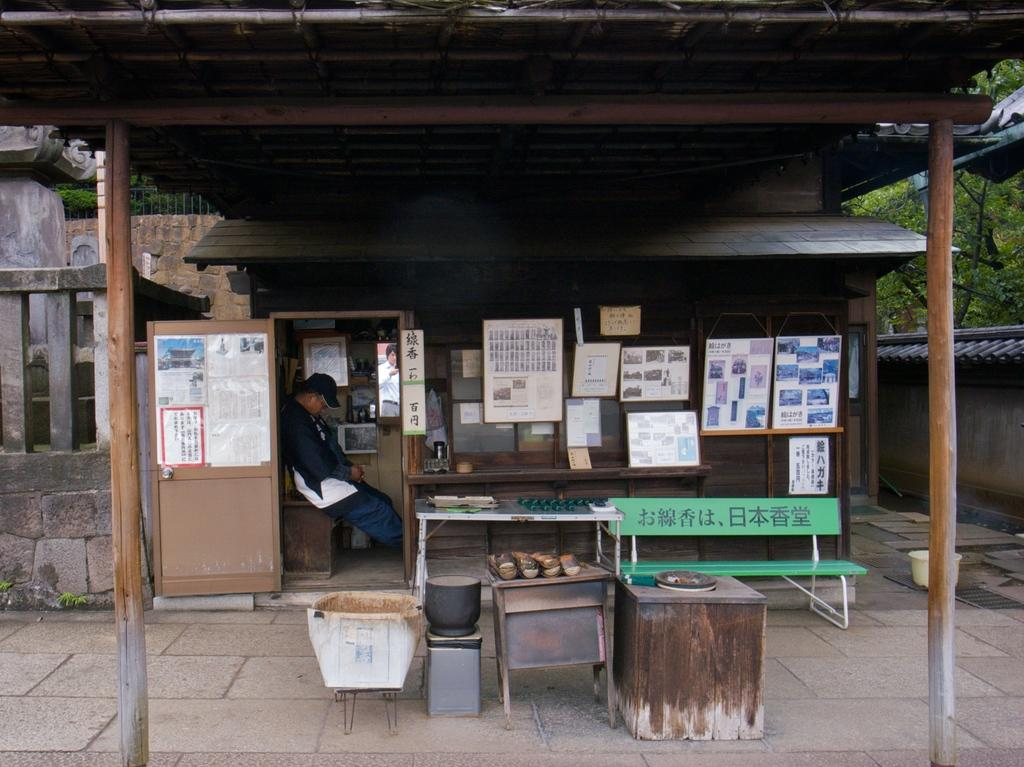What type of structure is visible in the image? There is a house in the image. What is the man in the image doing? The man is seated on a table in the image. What can be seen on the wall of the house? There are posts on the wall of the house in the image. What type of seating is present in the image? There is a bench in the image. Can you tell me how many horses are grazing on the farm in the image? There is no farm or horses present in the image; it features a house with a man seated on a table and a bench nearby. What type of winter clothing is the man wearing in the image? The man is not wearing any winter clothing, such as a mitten, in the image. 